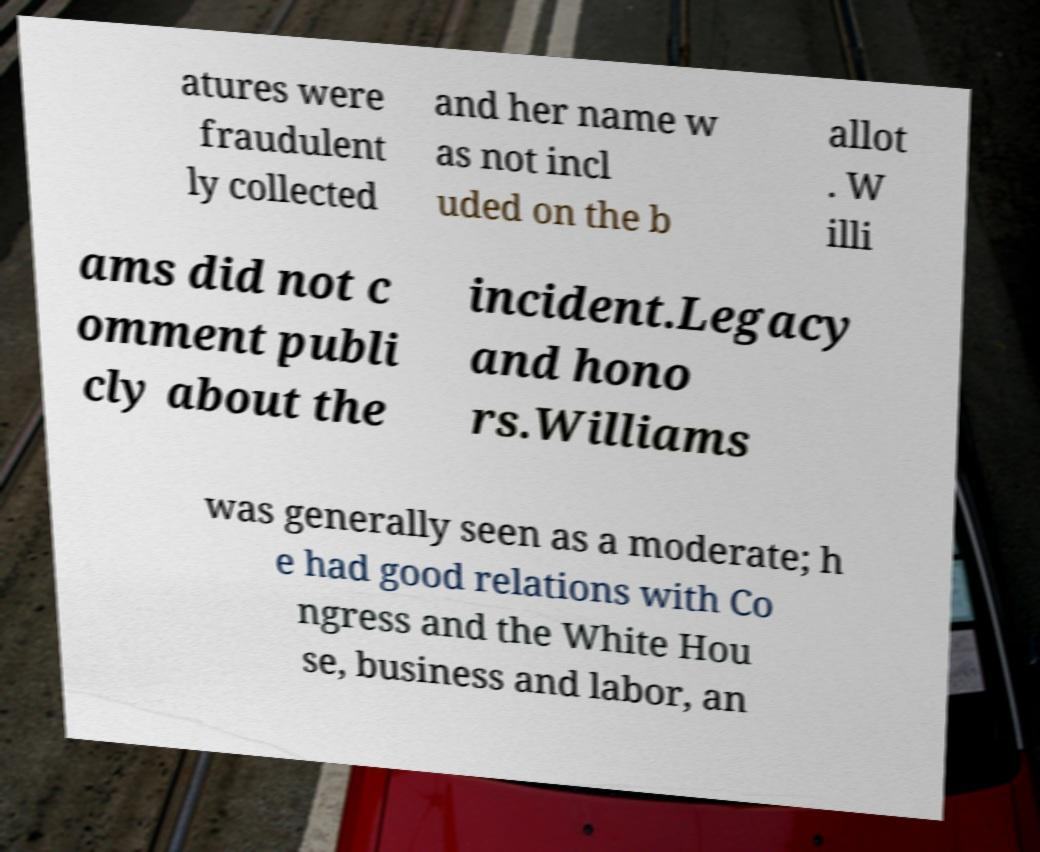There's text embedded in this image that I need extracted. Can you transcribe it verbatim? atures were fraudulent ly collected and her name w as not incl uded on the b allot . W illi ams did not c omment publi cly about the incident.Legacy and hono rs.Williams was generally seen as a moderate; h e had good relations with Co ngress and the White Hou se, business and labor, an 